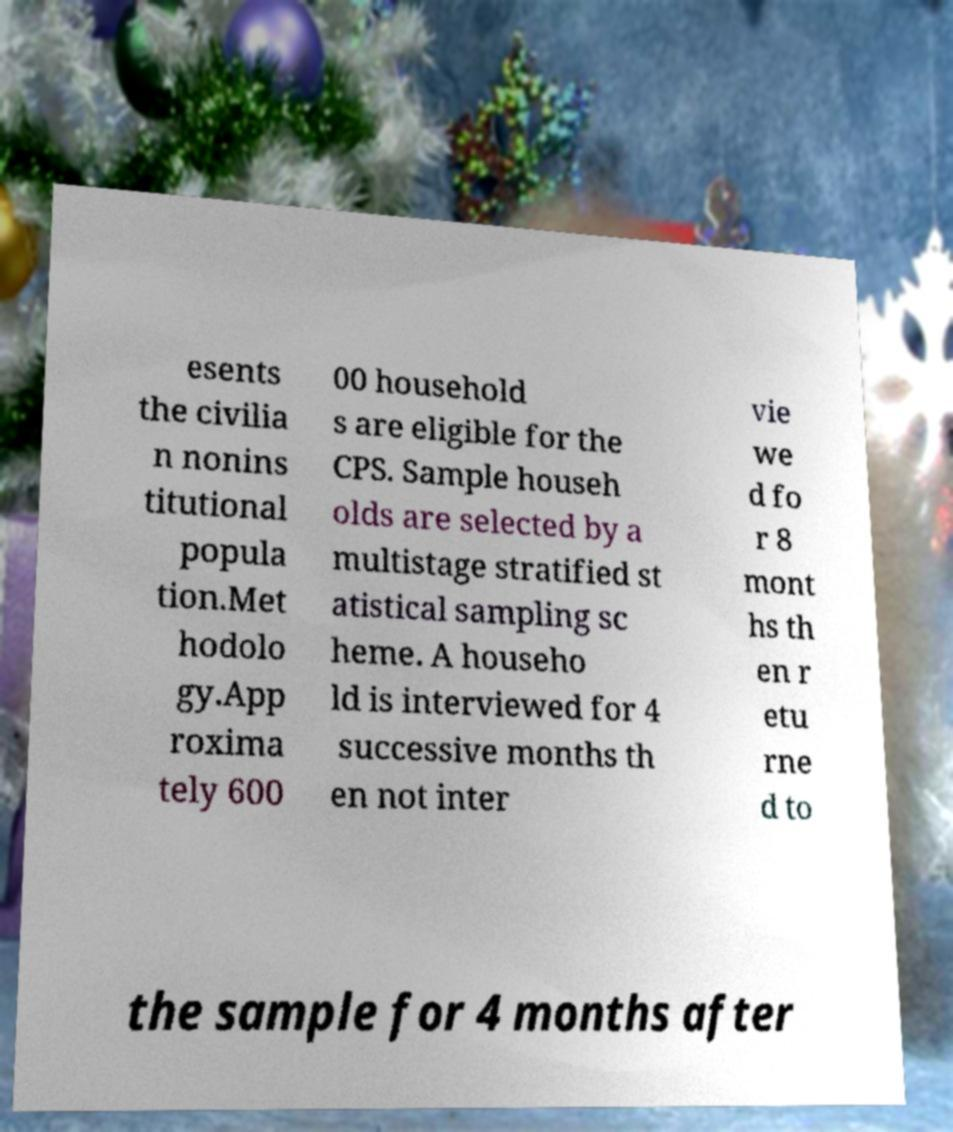There's text embedded in this image that I need extracted. Can you transcribe it verbatim? esents the civilia n nonins titutional popula tion.Met hodolo gy.App roxima tely 600 00 household s are eligible for the CPS. Sample househ olds are selected by a multistage stratified st atistical sampling sc heme. A househo ld is interviewed for 4 successive months th en not inter vie we d fo r 8 mont hs th en r etu rne d to the sample for 4 months after 